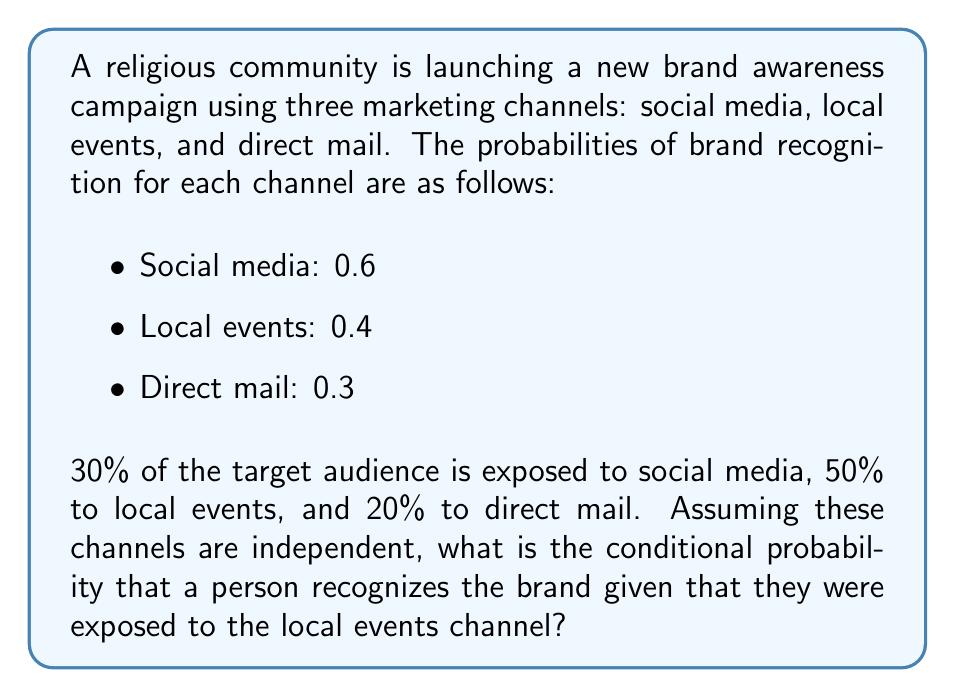Can you solve this math problem? Let's approach this step-by-step using Bayes' theorem:

1) Let B be the event of brand recognition, and E be the event of exposure to local events.

2) We need to find P(B|E), which is the probability of brand recognition given exposure to local events.

3) Bayes' theorem states:

   $$P(B|E) = \frac{P(E|B)P(B)}{P(E)}$$

4) We know P(E|B) = 0.4 (probability of local events given brand recognition)
   We know P(E) = 0.5 (50% of audience exposed to local events)

5) We need to calculate P(B), the overall probability of brand recognition:

   $$P(B) = 1 - P(\text{no recognition})$$
   $$P(\text{no recognition}) = (1-0.6)^{0.3} \cdot (1-0.4)^{0.5} \cdot (1-0.3)^{0.2}$$
   $$P(\text{no recognition}) = 0.4^{0.3} \cdot 0.6^{0.5} \cdot 0.7^{0.2} \approx 0.5404$$
   $$P(B) = 1 - 0.5404 = 0.4596$$

6) Now we can apply Bayes' theorem:

   $$P(B|E) = \frac{0.4 \cdot 0.4596}{0.5} \approx 0.3677$$

Therefore, the conditional probability of brand recognition given exposure to local events is approximately 0.3677 or 36.77%.
Answer: 0.3677 